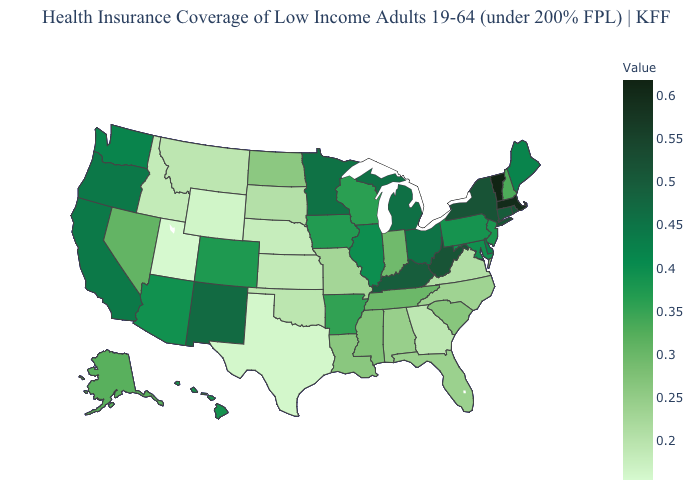Does Vermont have the highest value in the Northeast?
Concise answer only. Yes. Among the states that border South Carolina , does North Carolina have the lowest value?
Write a very short answer. No. Among the states that border Idaho , which have the lowest value?
Keep it brief. Utah. 